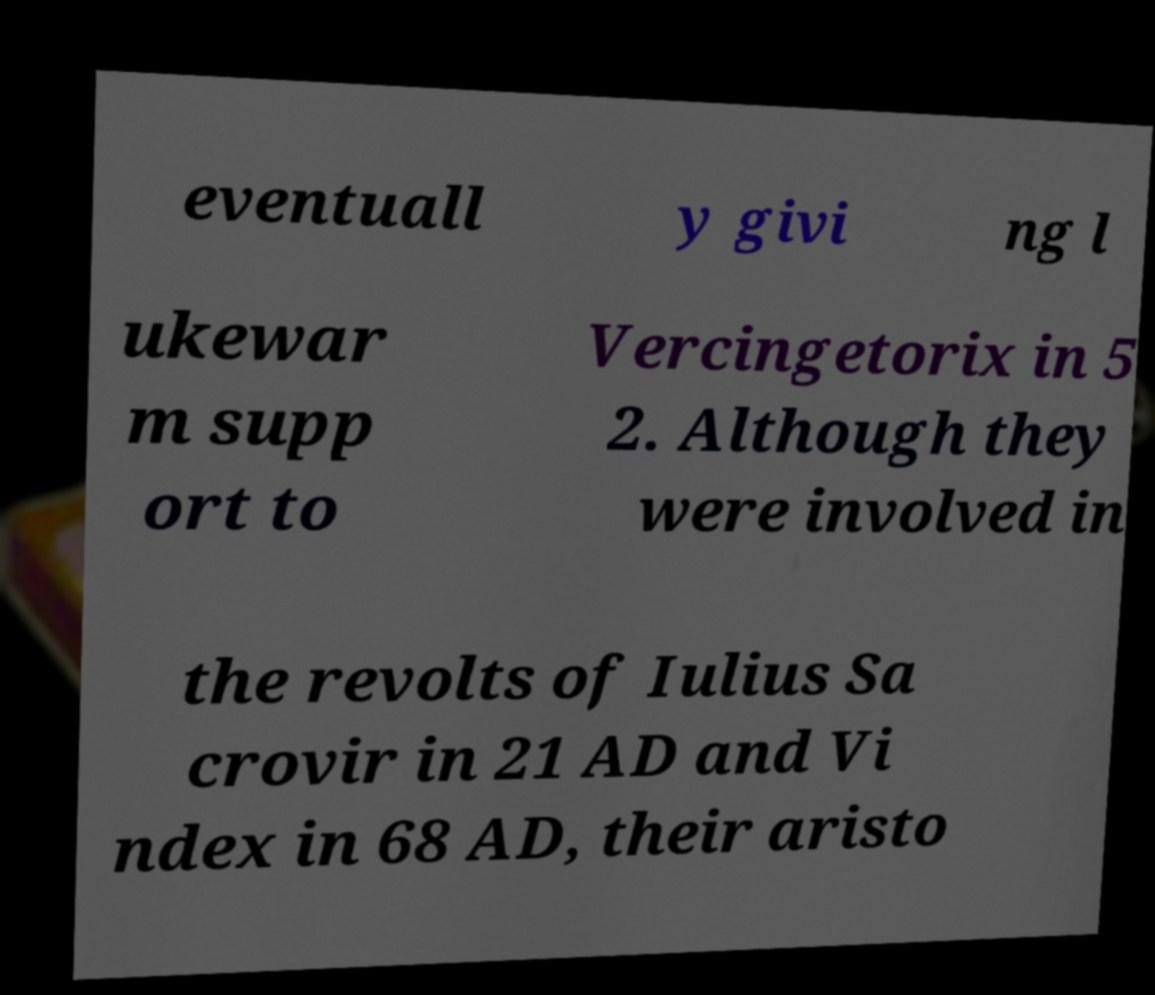Could you assist in decoding the text presented in this image and type it out clearly? eventuall y givi ng l ukewar m supp ort to Vercingetorix in 5 2. Although they were involved in the revolts of Iulius Sa crovir in 21 AD and Vi ndex in 68 AD, their aristo 